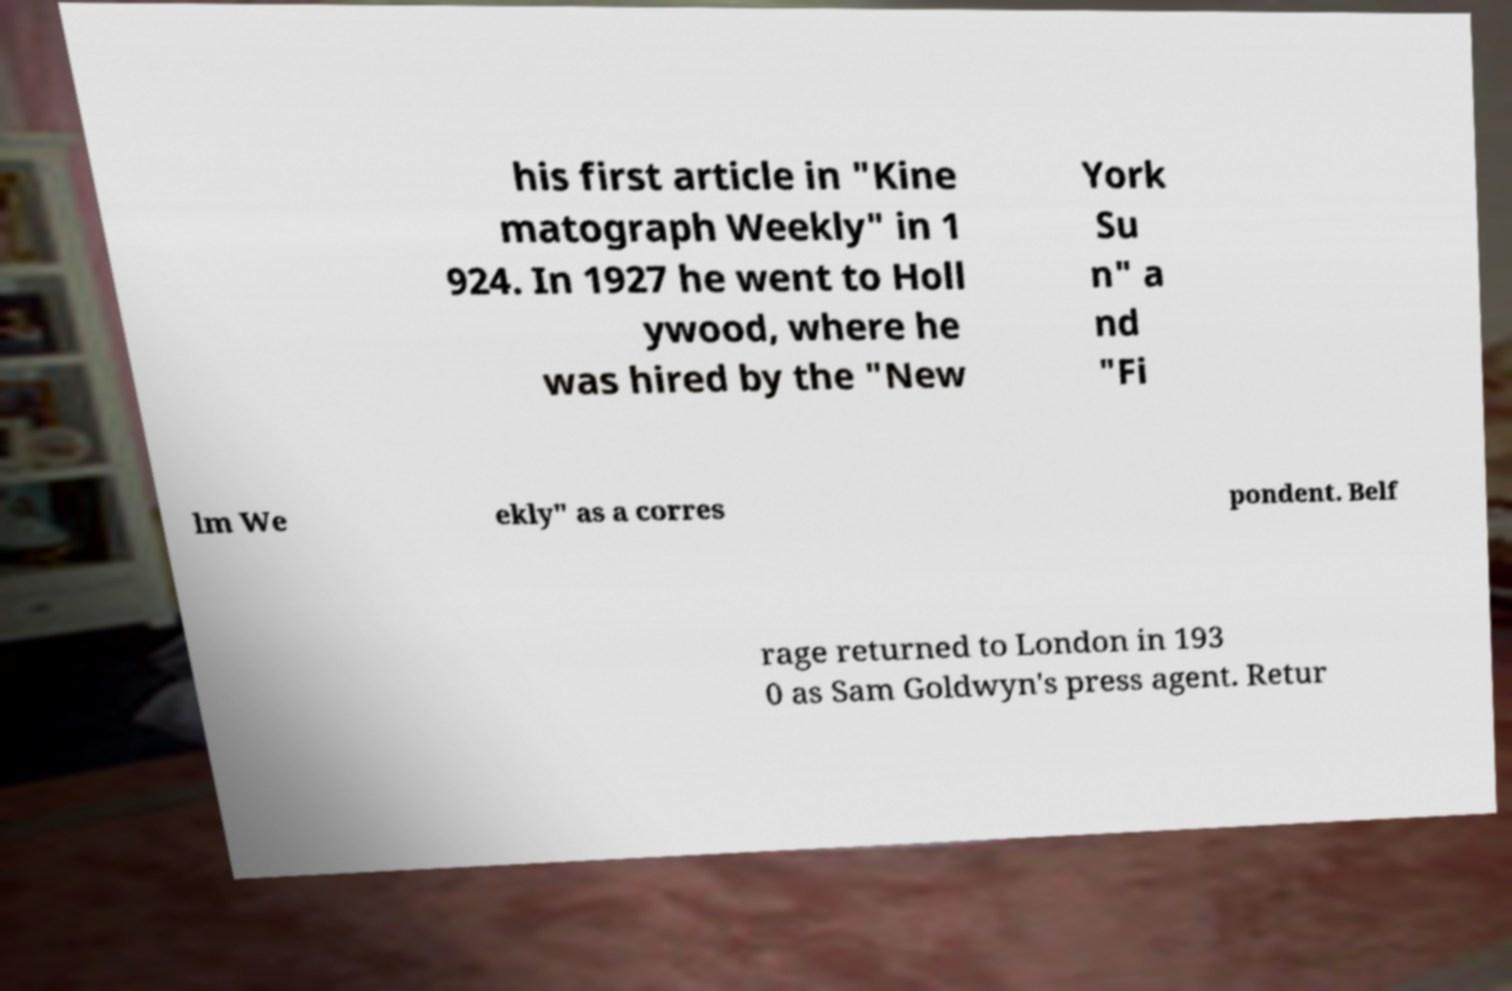I need the written content from this picture converted into text. Can you do that? his first article in "Kine matograph Weekly" in 1 924. In 1927 he went to Holl ywood, where he was hired by the "New York Su n" a nd "Fi lm We ekly" as a corres pondent. Belf rage returned to London in 193 0 as Sam Goldwyn's press agent. Retur 